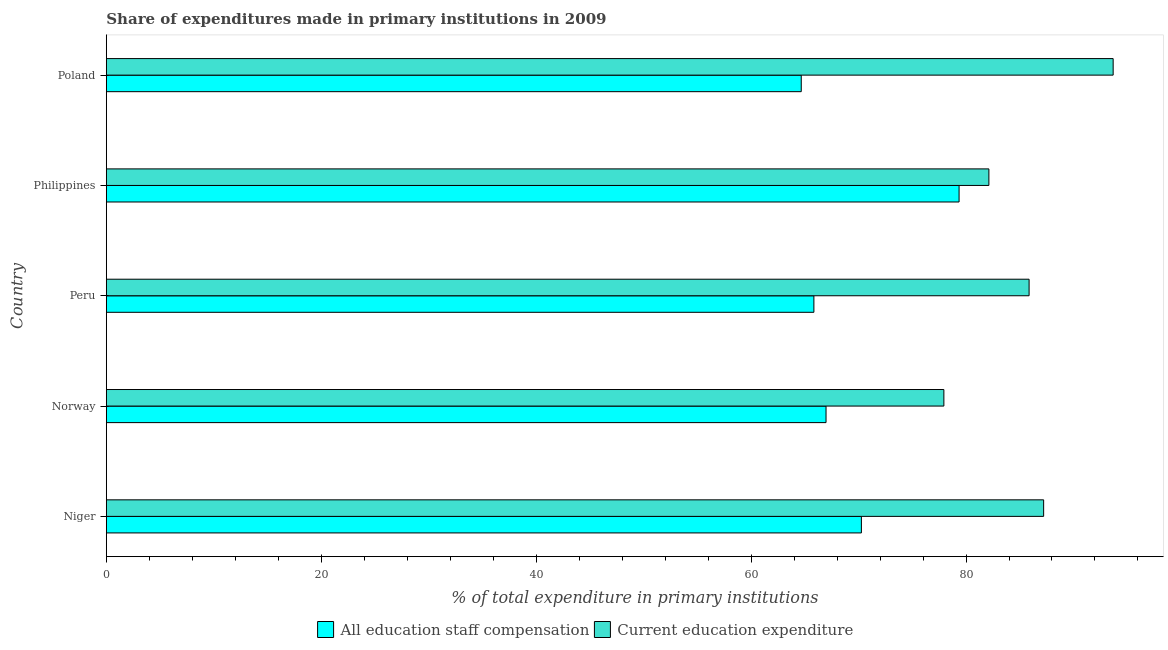How many different coloured bars are there?
Provide a short and direct response. 2. Are the number of bars on each tick of the Y-axis equal?
Offer a terse response. Yes. How many bars are there on the 2nd tick from the top?
Provide a short and direct response. 2. How many bars are there on the 3rd tick from the bottom?
Provide a succinct answer. 2. What is the label of the 2nd group of bars from the top?
Ensure brevity in your answer.  Philippines. What is the expenditure in staff compensation in Poland?
Ensure brevity in your answer.  64.67. Across all countries, what is the maximum expenditure in staff compensation?
Offer a terse response. 79.35. Across all countries, what is the minimum expenditure in staff compensation?
Offer a terse response. 64.67. In which country was the expenditure in staff compensation maximum?
Offer a very short reply. Philippines. What is the total expenditure in education in the graph?
Give a very brief answer. 426.85. What is the difference between the expenditure in staff compensation in Norway and that in Philippines?
Provide a short and direct response. -12.38. What is the difference between the expenditure in education in Philippines and the expenditure in staff compensation in Peru?
Provide a succinct answer. 16.28. What is the average expenditure in staff compensation per country?
Your answer should be compact. 69.42. What is the difference between the expenditure in education and expenditure in staff compensation in Peru?
Your answer should be compact. 20.03. What is the ratio of the expenditure in education in Norway to that in Poland?
Your response must be concise. 0.83. What is the difference between the highest and the second highest expenditure in education?
Offer a very short reply. 6.47. What is the difference between the highest and the lowest expenditure in staff compensation?
Keep it short and to the point. 14.69. Is the sum of the expenditure in education in Norway and Peru greater than the maximum expenditure in staff compensation across all countries?
Give a very brief answer. Yes. What does the 1st bar from the top in Poland represents?
Your response must be concise. Current education expenditure. What does the 2nd bar from the bottom in Peru represents?
Ensure brevity in your answer.  Current education expenditure. How many bars are there?
Your answer should be compact. 10. Are all the bars in the graph horizontal?
Offer a terse response. Yes. What is the difference between two consecutive major ticks on the X-axis?
Provide a short and direct response. 20. Does the graph contain any zero values?
Make the answer very short. No. Does the graph contain grids?
Your response must be concise. No. Where does the legend appear in the graph?
Your answer should be very brief. Bottom center. How many legend labels are there?
Ensure brevity in your answer.  2. How are the legend labels stacked?
Provide a succinct answer. Horizontal. What is the title of the graph?
Your answer should be compact. Share of expenditures made in primary institutions in 2009. Does "Birth rate" appear as one of the legend labels in the graph?
Offer a terse response. No. What is the label or title of the X-axis?
Provide a short and direct response. % of total expenditure in primary institutions. What is the % of total expenditure in primary institutions of All education staff compensation in Niger?
Offer a terse response. 70.26. What is the % of total expenditure in primary institutions of Current education expenditure in Niger?
Ensure brevity in your answer.  87.22. What is the % of total expenditure in primary institutions of All education staff compensation in Norway?
Offer a very short reply. 66.97. What is the % of total expenditure in primary institutions in Current education expenditure in Norway?
Make the answer very short. 77.94. What is the % of total expenditure in primary institutions in All education staff compensation in Peru?
Your answer should be compact. 65.84. What is the % of total expenditure in primary institutions of Current education expenditure in Peru?
Offer a terse response. 85.87. What is the % of total expenditure in primary institutions of All education staff compensation in Philippines?
Make the answer very short. 79.35. What is the % of total expenditure in primary institutions in Current education expenditure in Philippines?
Keep it short and to the point. 82.13. What is the % of total expenditure in primary institutions in All education staff compensation in Poland?
Keep it short and to the point. 64.67. What is the % of total expenditure in primary institutions in Current education expenditure in Poland?
Offer a terse response. 93.69. Across all countries, what is the maximum % of total expenditure in primary institutions of All education staff compensation?
Provide a short and direct response. 79.35. Across all countries, what is the maximum % of total expenditure in primary institutions of Current education expenditure?
Provide a short and direct response. 93.69. Across all countries, what is the minimum % of total expenditure in primary institutions of All education staff compensation?
Provide a short and direct response. 64.67. Across all countries, what is the minimum % of total expenditure in primary institutions of Current education expenditure?
Give a very brief answer. 77.94. What is the total % of total expenditure in primary institutions of All education staff compensation in the graph?
Offer a terse response. 347.1. What is the total % of total expenditure in primary institutions of Current education expenditure in the graph?
Offer a very short reply. 426.85. What is the difference between the % of total expenditure in primary institutions in All education staff compensation in Niger and that in Norway?
Ensure brevity in your answer.  3.29. What is the difference between the % of total expenditure in primary institutions of Current education expenditure in Niger and that in Norway?
Keep it short and to the point. 9.28. What is the difference between the % of total expenditure in primary institutions of All education staff compensation in Niger and that in Peru?
Provide a short and direct response. 4.42. What is the difference between the % of total expenditure in primary institutions in Current education expenditure in Niger and that in Peru?
Your answer should be compact. 1.35. What is the difference between the % of total expenditure in primary institutions in All education staff compensation in Niger and that in Philippines?
Make the answer very short. -9.09. What is the difference between the % of total expenditure in primary institutions in Current education expenditure in Niger and that in Philippines?
Make the answer very short. 5.1. What is the difference between the % of total expenditure in primary institutions of All education staff compensation in Niger and that in Poland?
Your response must be concise. 5.6. What is the difference between the % of total expenditure in primary institutions of Current education expenditure in Niger and that in Poland?
Give a very brief answer. -6.47. What is the difference between the % of total expenditure in primary institutions of All education staff compensation in Norway and that in Peru?
Offer a terse response. 1.13. What is the difference between the % of total expenditure in primary institutions in Current education expenditure in Norway and that in Peru?
Ensure brevity in your answer.  -7.93. What is the difference between the % of total expenditure in primary institutions of All education staff compensation in Norway and that in Philippines?
Provide a short and direct response. -12.38. What is the difference between the % of total expenditure in primary institutions in Current education expenditure in Norway and that in Philippines?
Make the answer very short. -4.19. What is the difference between the % of total expenditure in primary institutions of All education staff compensation in Norway and that in Poland?
Your answer should be very brief. 2.31. What is the difference between the % of total expenditure in primary institutions in Current education expenditure in Norway and that in Poland?
Your answer should be compact. -15.75. What is the difference between the % of total expenditure in primary institutions in All education staff compensation in Peru and that in Philippines?
Give a very brief answer. -13.51. What is the difference between the % of total expenditure in primary institutions in Current education expenditure in Peru and that in Philippines?
Offer a very short reply. 3.74. What is the difference between the % of total expenditure in primary institutions in All education staff compensation in Peru and that in Poland?
Offer a terse response. 1.18. What is the difference between the % of total expenditure in primary institutions of Current education expenditure in Peru and that in Poland?
Your answer should be very brief. -7.82. What is the difference between the % of total expenditure in primary institutions of All education staff compensation in Philippines and that in Poland?
Your answer should be very brief. 14.69. What is the difference between the % of total expenditure in primary institutions of Current education expenditure in Philippines and that in Poland?
Provide a short and direct response. -11.56. What is the difference between the % of total expenditure in primary institutions of All education staff compensation in Niger and the % of total expenditure in primary institutions of Current education expenditure in Norway?
Ensure brevity in your answer.  -7.68. What is the difference between the % of total expenditure in primary institutions in All education staff compensation in Niger and the % of total expenditure in primary institutions in Current education expenditure in Peru?
Your response must be concise. -15.61. What is the difference between the % of total expenditure in primary institutions of All education staff compensation in Niger and the % of total expenditure in primary institutions of Current education expenditure in Philippines?
Give a very brief answer. -11.86. What is the difference between the % of total expenditure in primary institutions of All education staff compensation in Niger and the % of total expenditure in primary institutions of Current education expenditure in Poland?
Make the answer very short. -23.43. What is the difference between the % of total expenditure in primary institutions in All education staff compensation in Norway and the % of total expenditure in primary institutions in Current education expenditure in Peru?
Your response must be concise. -18.9. What is the difference between the % of total expenditure in primary institutions of All education staff compensation in Norway and the % of total expenditure in primary institutions of Current education expenditure in Philippines?
Offer a very short reply. -15.15. What is the difference between the % of total expenditure in primary institutions in All education staff compensation in Norway and the % of total expenditure in primary institutions in Current education expenditure in Poland?
Give a very brief answer. -26.72. What is the difference between the % of total expenditure in primary institutions of All education staff compensation in Peru and the % of total expenditure in primary institutions of Current education expenditure in Philippines?
Give a very brief answer. -16.28. What is the difference between the % of total expenditure in primary institutions in All education staff compensation in Peru and the % of total expenditure in primary institutions in Current education expenditure in Poland?
Your response must be concise. -27.85. What is the difference between the % of total expenditure in primary institutions in All education staff compensation in Philippines and the % of total expenditure in primary institutions in Current education expenditure in Poland?
Your answer should be compact. -14.34. What is the average % of total expenditure in primary institutions in All education staff compensation per country?
Your response must be concise. 69.42. What is the average % of total expenditure in primary institutions of Current education expenditure per country?
Keep it short and to the point. 85.37. What is the difference between the % of total expenditure in primary institutions of All education staff compensation and % of total expenditure in primary institutions of Current education expenditure in Niger?
Offer a terse response. -16.96. What is the difference between the % of total expenditure in primary institutions of All education staff compensation and % of total expenditure in primary institutions of Current education expenditure in Norway?
Make the answer very short. -10.97. What is the difference between the % of total expenditure in primary institutions of All education staff compensation and % of total expenditure in primary institutions of Current education expenditure in Peru?
Make the answer very short. -20.03. What is the difference between the % of total expenditure in primary institutions in All education staff compensation and % of total expenditure in primary institutions in Current education expenditure in Philippines?
Ensure brevity in your answer.  -2.77. What is the difference between the % of total expenditure in primary institutions in All education staff compensation and % of total expenditure in primary institutions in Current education expenditure in Poland?
Make the answer very short. -29.02. What is the ratio of the % of total expenditure in primary institutions in All education staff compensation in Niger to that in Norway?
Your response must be concise. 1.05. What is the ratio of the % of total expenditure in primary institutions of Current education expenditure in Niger to that in Norway?
Provide a succinct answer. 1.12. What is the ratio of the % of total expenditure in primary institutions of All education staff compensation in Niger to that in Peru?
Offer a very short reply. 1.07. What is the ratio of the % of total expenditure in primary institutions in Current education expenditure in Niger to that in Peru?
Your response must be concise. 1.02. What is the ratio of the % of total expenditure in primary institutions of All education staff compensation in Niger to that in Philippines?
Make the answer very short. 0.89. What is the ratio of the % of total expenditure in primary institutions in Current education expenditure in Niger to that in Philippines?
Provide a short and direct response. 1.06. What is the ratio of the % of total expenditure in primary institutions in All education staff compensation in Niger to that in Poland?
Offer a terse response. 1.09. What is the ratio of the % of total expenditure in primary institutions in Current education expenditure in Niger to that in Poland?
Your answer should be very brief. 0.93. What is the ratio of the % of total expenditure in primary institutions in All education staff compensation in Norway to that in Peru?
Make the answer very short. 1.02. What is the ratio of the % of total expenditure in primary institutions of Current education expenditure in Norway to that in Peru?
Offer a very short reply. 0.91. What is the ratio of the % of total expenditure in primary institutions of All education staff compensation in Norway to that in Philippines?
Your answer should be very brief. 0.84. What is the ratio of the % of total expenditure in primary institutions in Current education expenditure in Norway to that in Philippines?
Offer a very short reply. 0.95. What is the ratio of the % of total expenditure in primary institutions of All education staff compensation in Norway to that in Poland?
Provide a short and direct response. 1.04. What is the ratio of the % of total expenditure in primary institutions of Current education expenditure in Norway to that in Poland?
Your answer should be very brief. 0.83. What is the ratio of the % of total expenditure in primary institutions of All education staff compensation in Peru to that in Philippines?
Your answer should be compact. 0.83. What is the ratio of the % of total expenditure in primary institutions of Current education expenditure in Peru to that in Philippines?
Your answer should be very brief. 1.05. What is the ratio of the % of total expenditure in primary institutions of All education staff compensation in Peru to that in Poland?
Ensure brevity in your answer.  1.02. What is the ratio of the % of total expenditure in primary institutions in Current education expenditure in Peru to that in Poland?
Make the answer very short. 0.92. What is the ratio of the % of total expenditure in primary institutions of All education staff compensation in Philippines to that in Poland?
Your answer should be very brief. 1.23. What is the ratio of the % of total expenditure in primary institutions of Current education expenditure in Philippines to that in Poland?
Make the answer very short. 0.88. What is the difference between the highest and the second highest % of total expenditure in primary institutions of All education staff compensation?
Give a very brief answer. 9.09. What is the difference between the highest and the second highest % of total expenditure in primary institutions of Current education expenditure?
Keep it short and to the point. 6.47. What is the difference between the highest and the lowest % of total expenditure in primary institutions of All education staff compensation?
Keep it short and to the point. 14.69. What is the difference between the highest and the lowest % of total expenditure in primary institutions of Current education expenditure?
Offer a terse response. 15.75. 